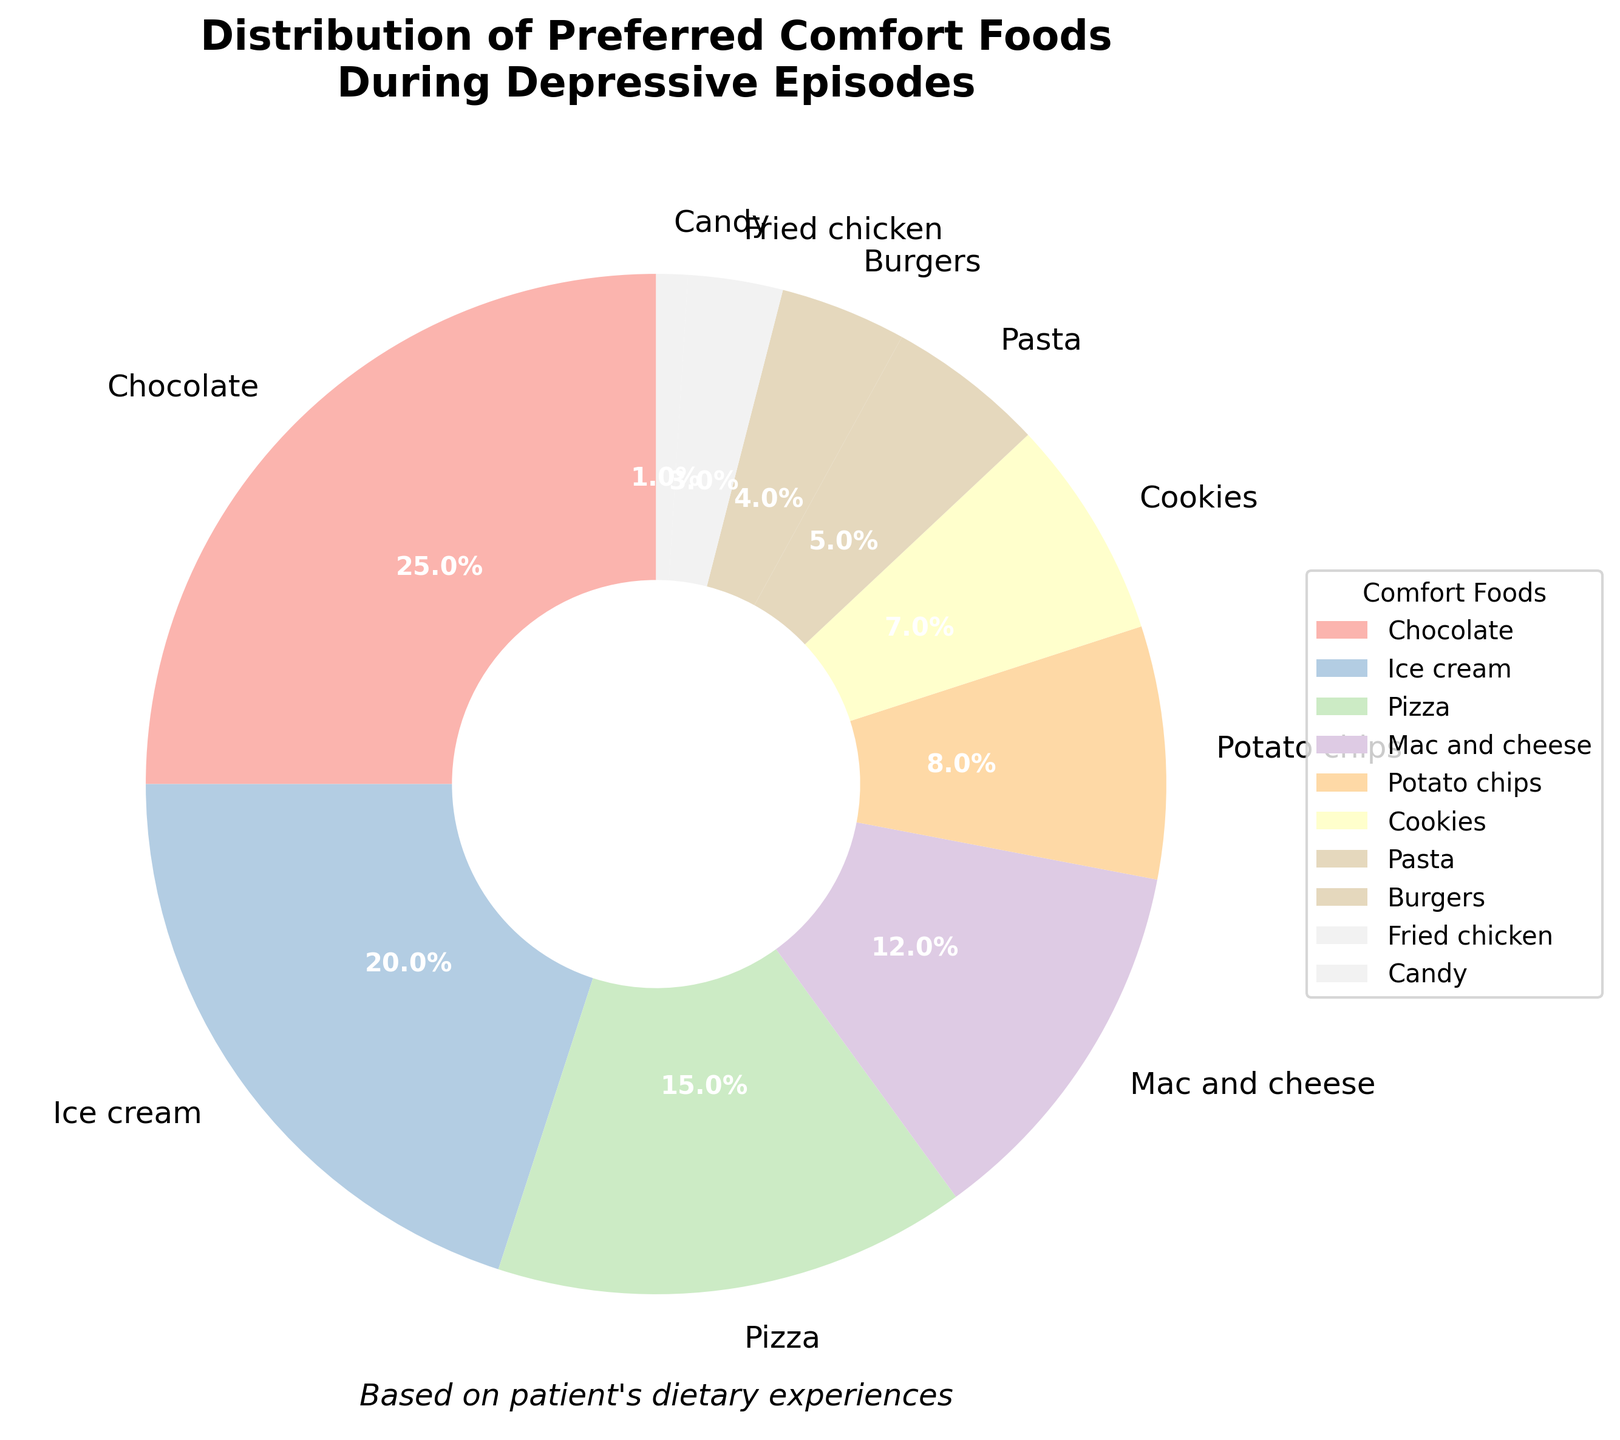What is the most preferred comfort food during depressive episodes? The figure shows a pie chart with different comfort foods and their respective percentages. The segment with the highest percentage should be the most preferred. In this case, "Chocolate" has the largest segment at 25%.
Answer: Chocolate Which comfort food has the lowest preference during depressive episodes? By examining the pie chart, the segment with the smallest percentage represents the least preferred comfort food. Here, "Candy" has the smallest segment at 1%.
Answer: Candy What is the combined percentage of people who prefer pizza and burgers during depressive episodes? To find the combined percentage, sum the percentages of both "Pizza" (15%) and "Burgers" (4%). Therefore, the combined percentage is 15 + 4 = 19%.
Answer: 19% Compare the preference for ice cream and cookies during depressive episodes. Which one is preferred more and by how much? According to the pie chart, "Ice cream" has a percentage of 20%, while "Cookies" have 7%. To find out how much more "Ice cream" is preferred, subtract the percentage of "Cookies" from that of "Ice cream": 20% - 7% = 13%.
Answer: Ice cream by 13% Are there more people who prefer pasta or potato chips during depressive episodes? In the pie chart, "Pasta" has a percentage of 5%, and "Potato chips" are at 8%. Since 8% is greater than 5%, more people prefer potato chips over pasta.
Answer: Potato chips How much more preferred is mac and cheese compared to fried chicken during depressive episodes? The pie chart shows that "Mac and cheese" has a percentage of 12%, while "Fried chicken" has 3%. The difference in preference is calculated by subtracting the percentage of "Fried chicken" from "Mac and cheese": 12% - 3% = 9%.
Answer: 9% What is the second most preferred comfort food during depressive episodes, and what percentage does it represent? The pie chart displays "Ice cream" as the second largest segment, indicating it is the second most preferred comfort food. The corresponding percentage for ice cream is 20%.
Answer: Ice cream, 20% What is the average percentage of the top three most preferred comfort foods during depressive episodes? The top three most preferred comfort foods based on the pie chart are "Chocolate" (25%), "Ice cream" (20%), and "Pizza" (15%). To find the average, sum these percentages and divide by 3: (25 + 20 + 15) / 3 = 60 / 3 = 20%.
Answer: 20% How does the preference for cookies compare to that of mac and cheese? From the pie chart, "Cookies" have a percentage of 7%, and "Mac and cheese" is at 12%. By comparing these percentages, it’s clear that "Mac and cheese" is preferred more than "Cookies."
Answer: Mac and cheese is preferred more What percentage of people prefer either chocolate or ice cream during depressive episodes? To find the combined percentage of people who prefer either "Chocolate" or "Ice cream," sum the percentages of both: 25% + 20% = 45%.
Answer: 45% 